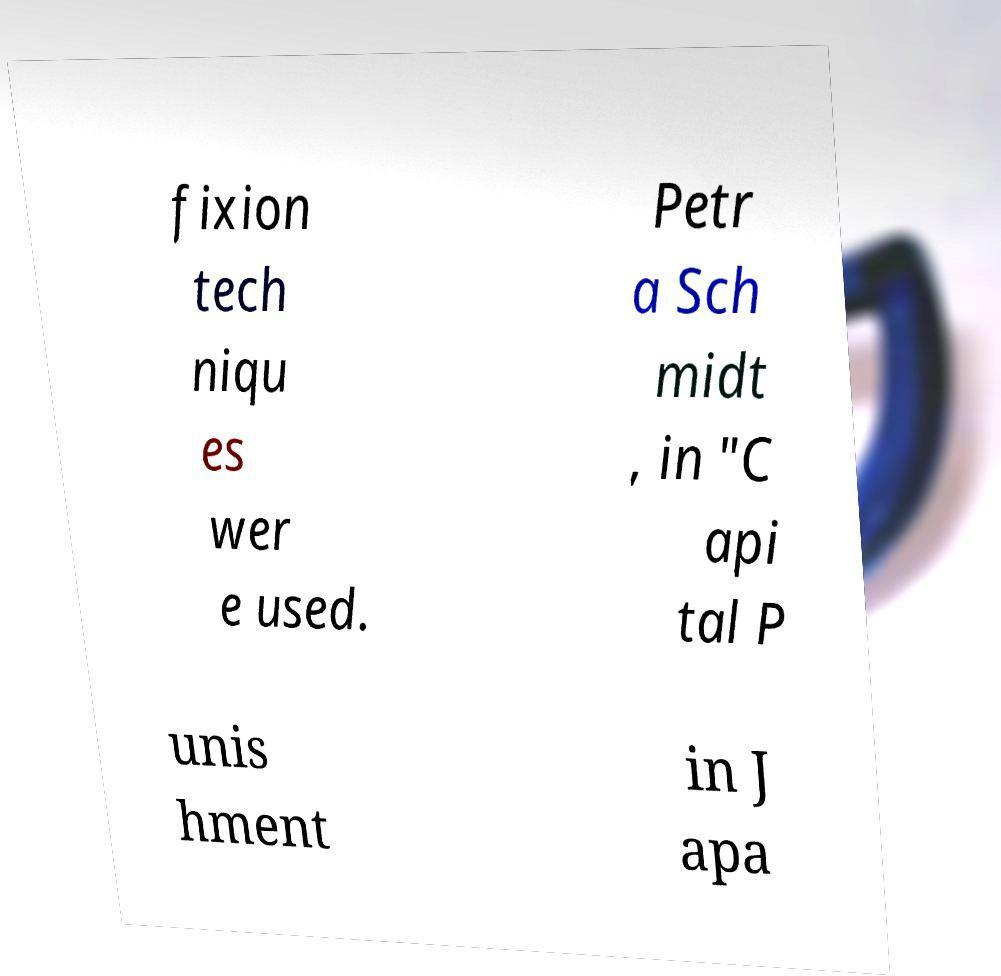I need the written content from this picture converted into text. Can you do that? fixion tech niqu es wer e used. Petr a Sch midt , in "C api tal P unis hment in J apa 